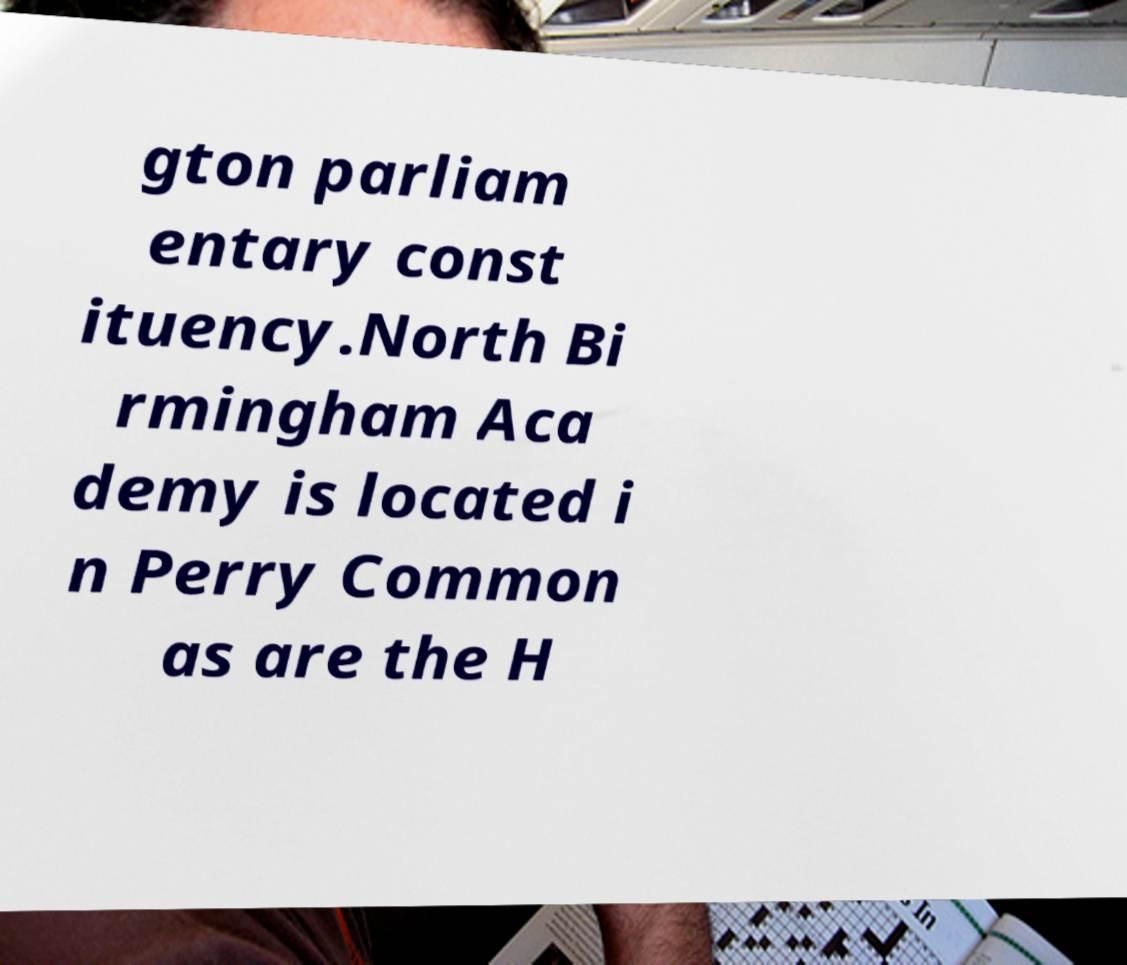Can you read and provide the text displayed in the image?This photo seems to have some interesting text. Can you extract and type it out for me? gton parliam entary const ituency.North Bi rmingham Aca demy is located i n Perry Common as are the H 